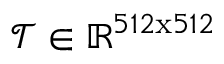Convert formula to latex. <formula><loc_0><loc_0><loc_500><loc_500>\mathcal { T } \in \mathbb { R } ^ { 5 1 2 x 5 1 2 }</formula> 